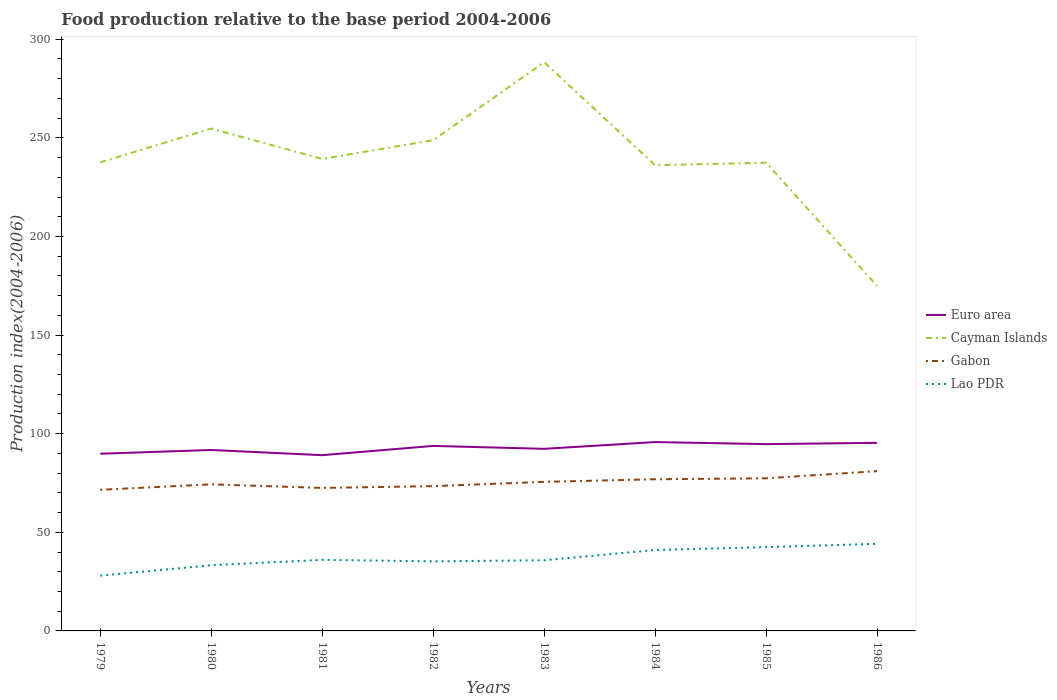How many different coloured lines are there?
Offer a terse response. 4. Does the line corresponding to Cayman Islands intersect with the line corresponding to Euro area?
Ensure brevity in your answer.  No. Is the number of lines equal to the number of legend labels?
Ensure brevity in your answer.  Yes. Across all years, what is the maximum food production index in Gabon?
Your answer should be very brief. 71.57. In which year was the food production index in Gabon maximum?
Give a very brief answer. 1979. What is the total food production index in Gabon in the graph?
Provide a succinct answer. -5.81. What is the difference between the highest and the second highest food production index in Gabon?
Keep it short and to the point. 9.44. What is the difference between the highest and the lowest food production index in Cayman Islands?
Ensure brevity in your answer.  3. Is the food production index in Lao PDR strictly greater than the food production index in Cayman Islands over the years?
Your answer should be compact. Yes. How many years are there in the graph?
Your answer should be very brief. 8. What is the difference between two consecutive major ticks on the Y-axis?
Make the answer very short. 50. Does the graph contain any zero values?
Provide a succinct answer. No. How many legend labels are there?
Keep it short and to the point. 4. What is the title of the graph?
Your answer should be very brief. Food production relative to the base period 2004-2006. What is the label or title of the Y-axis?
Your response must be concise. Production index(2004-2006). What is the Production index(2004-2006) of Euro area in 1979?
Give a very brief answer. 89.85. What is the Production index(2004-2006) in Cayman Islands in 1979?
Your response must be concise. 237.57. What is the Production index(2004-2006) of Gabon in 1979?
Offer a terse response. 71.57. What is the Production index(2004-2006) of Lao PDR in 1979?
Provide a succinct answer. 28.02. What is the Production index(2004-2006) in Euro area in 1980?
Provide a succinct answer. 91.74. What is the Production index(2004-2006) in Cayman Islands in 1980?
Provide a short and direct response. 254.7. What is the Production index(2004-2006) in Gabon in 1980?
Your response must be concise. 74.31. What is the Production index(2004-2006) of Lao PDR in 1980?
Offer a terse response. 33.3. What is the Production index(2004-2006) in Euro area in 1981?
Keep it short and to the point. 89.11. What is the Production index(2004-2006) of Cayman Islands in 1981?
Your response must be concise. 239.32. What is the Production index(2004-2006) of Gabon in 1981?
Your answer should be compact. 72.51. What is the Production index(2004-2006) in Lao PDR in 1981?
Your answer should be compact. 36.05. What is the Production index(2004-2006) in Euro area in 1982?
Provide a succinct answer. 93.8. What is the Production index(2004-2006) in Cayman Islands in 1982?
Offer a very short reply. 248.8. What is the Production index(2004-2006) in Gabon in 1982?
Offer a very short reply. 73.41. What is the Production index(2004-2006) in Lao PDR in 1982?
Make the answer very short. 35.27. What is the Production index(2004-2006) of Euro area in 1983?
Offer a terse response. 92.33. What is the Production index(2004-2006) in Cayman Islands in 1983?
Provide a succinct answer. 288.34. What is the Production index(2004-2006) of Gabon in 1983?
Provide a succinct answer. 75.58. What is the Production index(2004-2006) of Lao PDR in 1983?
Offer a terse response. 35.83. What is the Production index(2004-2006) of Euro area in 1984?
Provide a succinct answer. 95.76. What is the Production index(2004-2006) in Cayman Islands in 1984?
Make the answer very short. 236.12. What is the Production index(2004-2006) of Gabon in 1984?
Give a very brief answer. 76.9. What is the Production index(2004-2006) in Lao PDR in 1984?
Make the answer very short. 41.04. What is the Production index(2004-2006) of Euro area in 1985?
Provide a short and direct response. 94.71. What is the Production index(2004-2006) in Cayman Islands in 1985?
Keep it short and to the point. 237.41. What is the Production index(2004-2006) in Gabon in 1985?
Ensure brevity in your answer.  77.38. What is the Production index(2004-2006) of Lao PDR in 1985?
Your response must be concise. 42.48. What is the Production index(2004-2006) of Euro area in 1986?
Offer a very short reply. 95.37. What is the Production index(2004-2006) of Cayman Islands in 1986?
Keep it short and to the point. 174.84. What is the Production index(2004-2006) of Gabon in 1986?
Your answer should be very brief. 81.01. What is the Production index(2004-2006) in Lao PDR in 1986?
Provide a succinct answer. 44.16. Across all years, what is the maximum Production index(2004-2006) of Euro area?
Provide a succinct answer. 95.76. Across all years, what is the maximum Production index(2004-2006) of Cayman Islands?
Offer a very short reply. 288.34. Across all years, what is the maximum Production index(2004-2006) in Gabon?
Your response must be concise. 81.01. Across all years, what is the maximum Production index(2004-2006) of Lao PDR?
Offer a terse response. 44.16. Across all years, what is the minimum Production index(2004-2006) of Euro area?
Your answer should be compact. 89.11. Across all years, what is the minimum Production index(2004-2006) of Cayman Islands?
Your answer should be very brief. 174.84. Across all years, what is the minimum Production index(2004-2006) in Gabon?
Ensure brevity in your answer.  71.57. Across all years, what is the minimum Production index(2004-2006) in Lao PDR?
Your response must be concise. 28.02. What is the total Production index(2004-2006) in Euro area in the graph?
Your response must be concise. 742.67. What is the total Production index(2004-2006) in Cayman Islands in the graph?
Offer a terse response. 1917.1. What is the total Production index(2004-2006) of Gabon in the graph?
Keep it short and to the point. 602.67. What is the total Production index(2004-2006) of Lao PDR in the graph?
Keep it short and to the point. 296.15. What is the difference between the Production index(2004-2006) of Euro area in 1979 and that in 1980?
Make the answer very short. -1.89. What is the difference between the Production index(2004-2006) in Cayman Islands in 1979 and that in 1980?
Offer a terse response. -17.13. What is the difference between the Production index(2004-2006) of Gabon in 1979 and that in 1980?
Offer a terse response. -2.74. What is the difference between the Production index(2004-2006) of Lao PDR in 1979 and that in 1980?
Your answer should be compact. -5.28. What is the difference between the Production index(2004-2006) in Euro area in 1979 and that in 1981?
Provide a succinct answer. 0.74. What is the difference between the Production index(2004-2006) of Cayman Islands in 1979 and that in 1981?
Keep it short and to the point. -1.75. What is the difference between the Production index(2004-2006) in Gabon in 1979 and that in 1981?
Give a very brief answer. -0.94. What is the difference between the Production index(2004-2006) of Lao PDR in 1979 and that in 1981?
Offer a terse response. -8.03. What is the difference between the Production index(2004-2006) in Euro area in 1979 and that in 1982?
Your answer should be compact. -3.96. What is the difference between the Production index(2004-2006) in Cayman Islands in 1979 and that in 1982?
Give a very brief answer. -11.23. What is the difference between the Production index(2004-2006) in Gabon in 1979 and that in 1982?
Provide a short and direct response. -1.84. What is the difference between the Production index(2004-2006) in Lao PDR in 1979 and that in 1982?
Provide a succinct answer. -7.25. What is the difference between the Production index(2004-2006) in Euro area in 1979 and that in 1983?
Ensure brevity in your answer.  -2.48. What is the difference between the Production index(2004-2006) of Cayman Islands in 1979 and that in 1983?
Provide a succinct answer. -50.77. What is the difference between the Production index(2004-2006) of Gabon in 1979 and that in 1983?
Your answer should be compact. -4.01. What is the difference between the Production index(2004-2006) in Lao PDR in 1979 and that in 1983?
Your response must be concise. -7.81. What is the difference between the Production index(2004-2006) in Euro area in 1979 and that in 1984?
Give a very brief answer. -5.91. What is the difference between the Production index(2004-2006) in Cayman Islands in 1979 and that in 1984?
Provide a short and direct response. 1.45. What is the difference between the Production index(2004-2006) of Gabon in 1979 and that in 1984?
Provide a short and direct response. -5.33. What is the difference between the Production index(2004-2006) of Lao PDR in 1979 and that in 1984?
Ensure brevity in your answer.  -13.02. What is the difference between the Production index(2004-2006) of Euro area in 1979 and that in 1985?
Give a very brief answer. -4.86. What is the difference between the Production index(2004-2006) in Cayman Islands in 1979 and that in 1985?
Offer a very short reply. 0.16. What is the difference between the Production index(2004-2006) of Gabon in 1979 and that in 1985?
Your answer should be compact. -5.81. What is the difference between the Production index(2004-2006) in Lao PDR in 1979 and that in 1985?
Your response must be concise. -14.46. What is the difference between the Production index(2004-2006) of Euro area in 1979 and that in 1986?
Give a very brief answer. -5.52. What is the difference between the Production index(2004-2006) in Cayman Islands in 1979 and that in 1986?
Provide a succinct answer. 62.73. What is the difference between the Production index(2004-2006) in Gabon in 1979 and that in 1986?
Your answer should be very brief. -9.44. What is the difference between the Production index(2004-2006) of Lao PDR in 1979 and that in 1986?
Provide a succinct answer. -16.14. What is the difference between the Production index(2004-2006) in Euro area in 1980 and that in 1981?
Make the answer very short. 2.63. What is the difference between the Production index(2004-2006) of Cayman Islands in 1980 and that in 1981?
Keep it short and to the point. 15.38. What is the difference between the Production index(2004-2006) of Lao PDR in 1980 and that in 1981?
Offer a terse response. -2.75. What is the difference between the Production index(2004-2006) of Euro area in 1980 and that in 1982?
Provide a short and direct response. -2.06. What is the difference between the Production index(2004-2006) of Gabon in 1980 and that in 1982?
Provide a succinct answer. 0.9. What is the difference between the Production index(2004-2006) of Lao PDR in 1980 and that in 1982?
Give a very brief answer. -1.97. What is the difference between the Production index(2004-2006) of Euro area in 1980 and that in 1983?
Offer a very short reply. -0.59. What is the difference between the Production index(2004-2006) in Cayman Islands in 1980 and that in 1983?
Your response must be concise. -33.64. What is the difference between the Production index(2004-2006) in Gabon in 1980 and that in 1983?
Provide a short and direct response. -1.27. What is the difference between the Production index(2004-2006) in Lao PDR in 1980 and that in 1983?
Keep it short and to the point. -2.53. What is the difference between the Production index(2004-2006) of Euro area in 1980 and that in 1984?
Offer a very short reply. -4.02. What is the difference between the Production index(2004-2006) in Cayman Islands in 1980 and that in 1984?
Make the answer very short. 18.58. What is the difference between the Production index(2004-2006) of Gabon in 1980 and that in 1984?
Ensure brevity in your answer.  -2.59. What is the difference between the Production index(2004-2006) in Lao PDR in 1980 and that in 1984?
Provide a succinct answer. -7.74. What is the difference between the Production index(2004-2006) of Euro area in 1980 and that in 1985?
Your answer should be very brief. -2.97. What is the difference between the Production index(2004-2006) in Cayman Islands in 1980 and that in 1985?
Your answer should be compact. 17.29. What is the difference between the Production index(2004-2006) of Gabon in 1980 and that in 1985?
Make the answer very short. -3.07. What is the difference between the Production index(2004-2006) in Lao PDR in 1980 and that in 1985?
Give a very brief answer. -9.18. What is the difference between the Production index(2004-2006) of Euro area in 1980 and that in 1986?
Keep it short and to the point. -3.63. What is the difference between the Production index(2004-2006) in Cayman Islands in 1980 and that in 1986?
Provide a short and direct response. 79.86. What is the difference between the Production index(2004-2006) of Lao PDR in 1980 and that in 1986?
Make the answer very short. -10.86. What is the difference between the Production index(2004-2006) in Euro area in 1981 and that in 1982?
Offer a terse response. -4.69. What is the difference between the Production index(2004-2006) in Cayman Islands in 1981 and that in 1982?
Provide a short and direct response. -9.48. What is the difference between the Production index(2004-2006) in Gabon in 1981 and that in 1982?
Your answer should be compact. -0.9. What is the difference between the Production index(2004-2006) of Lao PDR in 1981 and that in 1982?
Make the answer very short. 0.78. What is the difference between the Production index(2004-2006) in Euro area in 1981 and that in 1983?
Your answer should be very brief. -3.22. What is the difference between the Production index(2004-2006) in Cayman Islands in 1981 and that in 1983?
Offer a very short reply. -49.02. What is the difference between the Production index(2004-2006) in Gabon in 1981 and that in 1983?
Give a very brief answer. -3.07. What is the difference between the Production index(2004-2006) of Lao PDR in 1981 and that in 1983?
Ensure brevity in your answer.  0.22. What is the difference between the Production index(2004-2006) of Euro area in 1981 and that in 1984?
Offer a terse response. -6.65. What is the difference between the Production index(2004-2006) of Gabon in 1981 and that in 1984?
Provide a succinct answer. -4.39. What is the difference between the Production index(2004-2006) of Lao PDR in 1981 and that in 1984?
Ensure brevity in your answer.  -4.99. What is the difference between the Production index(2004-2006) of Euro area in 1981 and that in 1985?
Your answer should be very brief. -5.6. What is the difference between the Production index(2004-2006) in Cayman Islands in 1981 and that in 1985?
Your response must be concise. 1.91. What is the difference between the Production index(2004-2006) of Gabon in 1981 and that in 1985?
Offer a very short reply. -4.87. What is the difference between the Production index(2004-2006) in Lao PDR in 1981 and that in 1985?
Provide a succinct answer. -6.43. What is the difference between the Production index(2004-2006) in Euro area in 1981 and that in 1986?
Your response must be concise. -6.26. What is the difference between the Production index(2004-2006) of Cayman Islands in 1981 and that in 1986?
Your answer should be very brief. 64.48. What is the difference between the Production index(2004-2006) of Lao PDR in 1981 and that in 1986?
Offer a very short reply. -8.11. What is the difference between the Production index(2004-2006) in Euro area in 1982 and that in 1983?
Your answer should be compact. 1.47. What is the difference between the Production index(2004-2006) in Cayman Islands in 1982 and that in 1983?
Give a very brief answer. -39.54. What is the difference between the Production index(2004-2006) of Gabon in 1982 and that in 1983?
Your answer should be very brief. -2.17. What is the difference between the Production index(2004-2006) of Lao PDR in 1982 and that in 1983?
Make the answer very short. -0.56. What is the difference between the Production index(2004-2006) of Euro area in 1982 and that in 1984?
Give a very brief answer. -1.95. What is the difference between the Production index(2004-2006) of Cayman Islands in 1982 and that in 1984?
Give a very brief answer. 12.68. What is the difference between the Production index(2004-2006) of Gabon in 1982 and that in 1984?
Provide a short and direct response. -3.49. What is the difference between the Production index(2004-2006) in Lao PDR in 1982 and that in 1984?
Offer a terse response. -5.77. What is the difference between the Production index(2004-2006) in Euro area in 1982 and that in 1985?
Your answer should be compact. -0.91. What is the difference between the Production index(2004-2006) in Cayman Islands in 1982 and that in 1985?
Provide a succinct answer. 11.39. What is the difference between the Production index(2004-2006) of Gabon in 1982 and that in 1985?
Offer a very short reply. -3.97. What is the difference between the Production index(2004-2006) of Lao PDR in 1982 and that in 1985?
Offer a terse response. -7.21. What is the difference between the Production index(2004-2006) in Euro area in 1982 and that in 1986?
Give a very brief answer. -1.56. What is the difference between the Production index(2004-2006) in Cayman Islands in 1982 and that in 1986?
Make the answer very short. 73.96. What is the difference between the Production index(2004-2006) of Lao PDR in 1982 and that in 1986?
Your answer should be compact. -8.89. What is the difference between the Production index(2004-2006) in Euro area in 1983 and that in 1984?
Keep it short and to the point. -3.43. What is the difference between the Production index(2004-2006) in Cayman Islands in 1983 and that in 1984?
Offer a terse response. 52.22. What is the difference between the Production index(2004-2006) in Gabon in 1983 and that in 1984?
Make the answer very short. -1.32. What is the difference between the Production index(2004-2006) of Lao PDR in 1983 and that in 1984?
Offer a terse response. -5.21. What is the difference between the Production index(2004-2006) of Euro area in 1983 and that in 1985?
Ensure brevity in your answer.  -2.38. What is the difference between the Production index(2004-2006) in Cayman Islands in 1983 and that in 1985?
Your answer should be very brief. 50.93. What is the difference between the Production index(2004-2006) of Gabon in 1983 and that in 1985?
Your response must be concise. -1.8. What is the difference between the Production index(2004-2006) of Lao PDR in 1983 and that in 1985?
Offer a very short reply. -6.65. What is the difference between the Production index(2004-2006) of Euro area in 1983 and that in 1986?
Your answer should be compact. -3.04. What is the difference between the Production index(2004-2006) of Cayman Islands in 1983 and that in 1986?
Your answer should be very brief. 113.5. What is the difference between the Production index(2004-2006) of Gabon in 1983 and that in 1986?
Make the answer very short. -5.43. What is the difference between the Production index(2004-2006) of Lao PDR in 1983 and that in 1986?
Offer a terse response. -8.33. What is the difference between the Production index(2004-2006) in Euro area in 1984 and that in 1985?
Make the answer very short. 1.05. What is the difference between the Production index(2004-2006) in Cayman Islands in 1984 and that in 1985?
Provide a succinct answer. -1.29. What is the difference between the Production index(2004-2006) of Gabon in 1984 and that in 1985?
Provide a succinct answer. -0.48. What is the difference between the Production index(2004-2006) in Lao PDR in 1984 and that in 1985?
Your answer should be compact. -1.44. What is the difference between the Production index(2004-2006) of Euro area in 1984 and that in 1986?
Your answer should be very brief. 0.39. What is the difference between the Production index(2004-2006) of Cayman Islands in 1984 and that in 1986?
Your response must be concise. 61.28. What is the difference between the Production index(2004-2006) in Gabon in 1984 and that in 1986?
Make the answer very short. -4.11. What is the difference between the Production index(2004-2006) of Lao PDR in 1984 and that in 1986?
Offer a terse response. -3.12. What is the difference between the Production index(2004-2006) of Euro area in 1985 and that in 1986?
Your answer should be very brief. -0.66. What is the difference between the Production index(2004-2006) of Cayman Islands in 1985 and that in 1986?
Your response must be concise. 62.57. What is the difference between the Production index(2004-2006) in Gabon in 1985 and that in 1986?
Ensure brevity in your answer.  -3.63. What is the difference between the Production index(2004-2006) of Lao PDR in 1985 and that in 1986?
Your answer should be compact. -1.68. What is the difference between the Production index(2004-2006) in Euro area in 1979 and the Production index(2004-2006) in Cayman Islands in 1980?
Offer a terse response. -164.85. What is the difference between the Production index(2004-2006) of Euro area in 1979 and the Production index(2004-2006) of Gabon in 1980?
Your answer should be very brief. 15.54. What is the difference between the Production index(2004-2006) of Euro area in 1979 and the Production index(2004-2006) of Lao PDR in 1980?
Provide a succinct answer. 56.55. What is the difference between the Production index(2004-2006) of Cayman Islands in 1979 and the Production index(2004-2006) of Gabon in 1980?
Provide a short and direct response. 163.26. What is the difference between the Production index(2004-2006) of Cayman Islands in 1979 and the Production index(2004-2006) of Lao PDR in 1980?
Your answer should be compact. 204.27. What is the difference between the Production index(2004-2006) in Gabon in 1979 and the Production index(2004-2006) in Lao PDR in 1980?
Your response must be concise. 38.27. What is the difference between the Production index(2004-2006) in Euro area in 1979 and the Production index(2004-2006) in Cayman Islands in 1981?
Provide a short and direct response. -149.47. What is the difference between the Production index(2004-2006) of Euro area in 1979 and the Production index(2004-2006) of Gabon in 1981?
Provide a short and direct response. 17.34. What is the difference between the Production index(2004-2006) of Euro area in 1979 and the Production index(2004-2006) of Lao PDR in 1981?
Your answer should be very brief. 53.8. What is the difference between the Production index(2004-2006) in Cayman Islands in 1979 and the Production index(2004-2006) in Gabon in 1981?
Provide a short and direct response. 165.06. What is the difference between the Production index(2004-2006) of Cayman Islands in 1979 and the Production index(2004-2006) of Lao PDR in 1981?
Make the answer very short. 201.52. What is the difference between the Production index(2004-2006) in Gabon in 1979 and the Production index(2004-2006) in Lao PDR in 1981?
Provide a short and direct response. 35.52. What is the difference between the Production index(2004-2006) in Euro area in 1979 and the Production index(2004-2006) in Cayman Islands in 1982?
Your response must be concise. -158.95. What is the difference between the Production index(2004-2006) in Euro area in 1979 and the Production index(2004-2006) in Gabon in 1982?
Your answer should be compact. 16.44. What is the difference between the Production index(2004-2006) of Euro area in 1979 and the Production index(2004-2006) of Lao PDR in 1982?
Provide a short and direct response. 54.58. What is the difference between the Production index(2004-2006) in Cayman Islands in 1979 and the Production index(2004-2006) in Gabon in 1982?
Provide a succinct answer. 164.16. What is the difference between the Production index(2004-2006) in Cayman Islands in 1979 and the Production index(2004-2006) in Lao PDR in 1982?
Ensure brevity in your answer.  202.3. What is the difference between the Production index(2004-2006) of Gabon in 1979 and the Production index(2004-2006) of Lao PDR in 1982?
Provide a short and direct response. 36.3. What is the difference between the Production index(2004-2006) of Euro area in 1979 and the Production index(2004-2006) of Cayman Islands in 1983?
Provide a short and direct response. -198.49. What is the difference between the Production index(2004-2006) in Euro area in 1979 and the Production index(2004-2006) in Gabon in 1983?
Your response must be concise. 14.27. What is the difference between the Production index(2004-2006) in Euro area in 1979 and the Production index(2004-2006) in Lao PDR in 1983?
Make the answer very short. 54.02. What is the difference between the Production index(2004-2006) in Cayman Islands in 1979 and the Production index(2004-2006) in Gabon in 1983?
Give a very brief answer. 161.99. What is the difference between the Production index(2004-2006) of Cayman Islands in 1979 and the Production index(2004-2006) of Lao PDR in 1983?
Provide a succinct answer. 201.74. What is the difference between the Production index(2004-2006) in Gabon in 1979 and the Production index(2004-2006) in Lao PDR in 1983?
Offer a terse response. 35.74. What is the difference between the Production index(2004-2006) of Euro area in 1979 and the Production index(2004-2006) of Cayman Islands in 1984?
Your answer should be very brief. -146.27. What is the difference between the Production index(2004-2006) of Euro area in 1979 and the Production index(2004-2006) of Gabon in 1984?
Your answer should be compact. 12.95. What is the difference between the Production index(2004-2006) of Euro area in 1979 and the Production index(2004-2006) of Lao PDR in 1984?
Offer a terse response. 48.81. What is the difference between the Production index(2004-2006) of Cayman Islands in 1979 and the Production index(2004-2006) of Gabon in 1984?
Give a very brief answer. 160.67. What is the difference between the Production index(2004-2006) of Cayman Islands in 1979 and the Production index(2004-2006) of Lao PDR in 1984?
Give a very brief answer. 196.53. What is the difference between the Production index(2004-2006) in Gabon in 1979 and the Production index(2004-2006) in Lao PDR in 1984?
Give a very brief answer. 30.53. What is the difference between the Production index(2004-2006) in Euro area in 1979 and the Production index(2004-2006) in Cayman Islands in 1985?
Offer a terse response. -147.56. What is the difference between the Production index(2004-2006) of Euro area in 1979 and the Production index(2004-2006) of Gabon in 1985?
Keep it short and to the point. 12.47. What is the difference between the Production index(2004-2006) in Euro area in 1979 and the Production index(2004-2006) in Lao PDR in 1985?
Provide a succinct answer. 47.37. What is the difference between the Production index(2004-2006) of Cayman Islands in 1979 and the Production index(2004-2006) of Gabon in 1985?
Your response must be concise. 160.19. What is the difference between the Production index(2004-2006) in Cayman Islands in 1979 and the Production index(2004-2006) in Lao PDR in 1985?
Provide a succinct answer. 195.09. What is the difference between the Production index(2004-2006) of Gabon in 1979 and the Production index(2004-2006) of Lao PDR in 1985?
Ensure brevity in your answer.  29.09. What is the difference between the Production index(2004-2006) in Euro area in 1979 and the Production index(2004-2006) in Cayman Islands in 1986?
Your response must be concise. -84.99. What is the difference between the Production index(2004-2006) in Euro area in 1979 and the Production index(2004-2006) in Gabon in 1986?
Your answer should be very brief. 8.84. What is the difference between the Production index(2004-2006) in Euro area in 1979 and the Production index(2004-2006) in Lao PDR in 1986?
Offer a very short reply. 45.69. What is the difference between the Production index(2004-2006) of Cayman Islands in 1979 and the Production index(2004-2006) of Gabon in 1986?
Provide a succinct answer. 156.56. What is the difference between the Production index(2004-2006) of Cayman Islands in 1979 and the Production index(2004-2006) of Lao PDR in 1986?
Provide a short and direct response. 193.41. What is the difference between the Production index(2004-2006) of Gabon in 1979 and the Production index(2004-2006) of Lao PDR in 1986?
Ensure brevity in your answer.  27.41. What is the difference between the Production index(2004-2006) of Euro area in 1980 and the Production index(2004-2006) of Cayman Islands in 1981?
Make the answer very short. -147.58. What is the difference between the Production index(2004-2006) of Euro area in 1980 and the Production index(2004-2006) of Gabon in 1981?
Your answer should be compact. 19.23. What is the difference between the Production index(2004-2006) in Euro area in 1980 and the Production index(2004-2006) in Lao PDR in 1981?
Your answer should be very brief. 55.69. What is the difference between the Production index(2004-2006) of Cayman Islands in 1980 and the Production index(2004-2006) of Gabon in 1981?
Your answer should be very brief. 182.19. What is the difference between the Production index(2004-2006) of Cayman Islands in 1980 and the Production index(2004-2006) of Lao PDR in 1981?
Offer a terse response. 218.65. What is the difference between the Production index(2004-2006) of Gabon in 1980 and the Production index(2004-2006) of Lao PDR in 1981?
Give a very brief answer. 38.26. What is the difference between the Production index(2004-2006) of Euro area in 1980 and the Production index(2004-2006) of Cayman Islands in 1982?
Your response must be concise. -157.06. What is the difference between the Production index(2004-2006) of Euro area in 1980 and the Production index(2004-2006) of Gabon in 1982?
Your answer should be very brief. 18.33. What is the difference between the Production index(2004-2006) in Euro area in 1980 and the Production index(2004-2006) in Lao PDR in 1982?
Keep it short and to the point. 56.47. What is the difference between the Production index(2004-2006) of Cayman Islands in 1980 and the Production index(2004-2006) of Gabon in 1982?
Provide a short and direct response. 181.29. What is the difference between the Production index(2004-2006) of Cayman Islands in 1980 and the Production index(2004-2006) of Lao PDR in 1982?
Keep it short and to the point. 219.43. What is the difference between the Production index(2004-2006) in Gabon in 1980 and the Production index(2004-2006) in Lao PDR in 1982?
Make the answer very short. 39.04. What is the difference between the Production index(2004-2006) of Euro area in 1980 and the Production index(2004-2006) of Cayman Islands in 1983?
Offer a terse response. -196.6. What is the difference between the Production index(2004-2006) in Euro area in 1980 and the Production index(2004-2006) in Gabon in 1983?
Give a very brief answer. 16.16. What is the difference between the Production index(2004-2006) of Euro area in 1980 and the Production index(2004-2006) of Lao PDR in 1983?
Make the answer very short. 55.91. What is the difference between the Production index(2004-2006) of Cayman Islands in 1980 and the Production index(2004-2006) of Gabon in 1983?
Offer a very short reply. 179.12. What is the difference between the Production index(2004-2006) of Cayman Islands in 1980 and the Production index(2004-2006) of Lao PDR in 1983?
Offer a terse response. 218.87. What is the difference between the Production index(2004-2006) in Gabon in 1980 and the Production index(2004-2006) in Lao PDR in 1983?
Your answer should be compact. 38.48. What is the difference between the Production index(2004-2006) of Euro area in 1980 and the Production index(2004-2006) of Cayman Islands in 1984?
Your answer should be compact. -144.38. What is the difference between the Production index(2004-2006) of Euro area in 1980 and the Production index(2004-2006) of Gabon in 1984?
Keep it short and to the point. 14.84. What is the difference between the Production index(2004-2006) in Euro area in 1980 and the Production index(2004-2006) in Lao PDR in 1984?
Make the answer very short. 50.7. What is the difference between the Production index(2004-2006) in Cayman Islands in 1980 and the Production index(2004-2006) in Gabon in 1984?
Give a very brief answer. 177.8. What is the difference between the Production index(2004-2006) in Cayman Islands in 1980 and the Production index(2004-2006) in Lao PDR in 1984?
Offer a terse response. 213.66. What is the difference between the Production index(2004-2006) of Gabon in 1980 and the Production index(2004-2006) of Lao PDR in 1984?
Keep it short and to the point. 33.27. What is the difference between the Production index(2004-2006) of Euro area in 1980 and the Production index(2004-2006) of Cayman Islands in 1985?
Ensure brevity in your answer.  -145.67. What is the difference between the Production index(2004-2006) of Euro area in 1980 and the Production index(2004-2006) of Gabon in 1985?
Keep it short and to the point. 14.36. What is the difference between the Production index(2004-2006) of Euro area in 1980 and the Production index(2004-2006) of Lao PDR in 1985?
Give a very brief answer. 49.26. What is the difference between the Production index(2004-2006) of Cayman Islands in 1980 and the Production index(2004-2006) of Gabon in 1985?
Offer a very short reply. 177.32. What is the difference between the Production index(2004-2006) in Cayman Islands in 1980 and the Production index(2004-2006) in Lao PDR in 1985?
Ensure brevity in your answer.  212.22. What is the difference between the Production index(2004-2006) in Gabon in 1980 and the Production index(2004-2006) in Lao PDR in 1985?
Provide a short and direct response. 31.83. What is the difference between the Production index(2004-2006) of Euro area in 1980 and the Production index(2004-2006) of Cayman Islands in 1986?
Ensure brevity in your answer.  -83.1. What is the difference between the Production index(2004-2006) in Euro area in 1980 and the Production index(2004-2006) in Gabon in 1986?
Your answer should be compact. 10.73. What is the difference between the Production index(2004-2006) in Euro area in 1980 and the Production index(2004-2006) in Lao PDR in 1986?
Provide a succinct answer. 47.58. What is the difference between the Production index(2004-2006) of Cayman Islands in 1980 and the Production index(2004-2006) of Gabon in 1986?
Ensure brevity in your answer.  173.69. What is the difference between the Production index(2004-2006) of Cayman Islands in 1980 and the Production index(2004-2006) of Lao PDR in 1986?
Your answer should be compact. 210.54. What is the difference between the Production index(2004-2006) in Gabon in 1980 and the Production index(2004-2006) in Lao PDR in 1986?
Your answer should be very brief. 30.15. What is the difference between the Production index(2004-2006) of Euro area in 1981 and the Production index(2004-2006) of Cayman Islands in 1982?
Offer a very short reply. -159.69. What is the difference between the Production index(2004-2006) in Euro area in 1981 and the Production index(2004-2006) in Gabon in 1982?
Provide a succinct answer. 15.7. What is the difference between the Production index(2004-2006) in Euro area in 1981 and the Production index(2004-2006) in Lao PDR in 1982?
Your response must be concise. 53.84. What is the difference between the Production index(2004-2006) in Cayman Islands in 1981 and the Production index(2004-2006) in Gabon in 1982?
Your answer should be compact. 165.91. What is the difference between the Production index(2004-2006) in Cayman Islands in 1981 and the Production index(2004-2006) in Lao PDR in 1982?
Keep it short and to the point. 204.05. What is the difference between the Production index(2004-2006) in Gabon in 1981 and the Production index(2004-2006) in Lao PDR in 1982?
Give a very brief answer. 37.24. What is the difference between the Production index(2004-2006) of Euro area in 1981 and the Production index(2004-2006) of Cayman Islands in 1983?
Give a very brief answer. -199.23. What is the difference between the Production index(2004-2006) of Euro area in 1981 and the Production index(2004-2006) of Gabon in 1983?
Ensure brevity in your answer.  13.53. What is the difference between the Production index(2004-2006) of Euro area in 1981 and the Production index(2004-2006) of Lao PDR in 1983?
Your answer should be compact. 53.28. What is the difference between the Production index(2004-2006) of Cayman Islands in 1981 and the Production index(2004-2006) of Gabon in 1983?
Your answer should be very brief. 163.74. What is the difference between the Production index(2004-2006) of Cayman Islands in 1981 and the Production index(2004-2006) of Lao PDR in 1983?
Offer a very short reply. 203.49. What is the difference between the Production index(2004-2006) in Gabon in 1981 and the Production index(2004-2006) in Lao PDR in 1983?
Your response must be concise. 36.68. What is the difference between the Production index(2004-2006) in Euro area in 1981 and the Production index(2004-2006) in Cayman Islands in 1984?
Make the answer very short. -147.01. What is the difference between the Production index(2004-2006) of Euro area in 1981 and the Production index(2004-2006) of Gabon in 1984?
Make the answer very short. 12.21. What is the difference between the Production index(2004-2006) of Euro area in 1981 and the Production index(2004-2006) of Lao PDR in 1984?
Provide a short and direct response. 48.07. What is the difference between the Production index(2004-2006) in Cayman Islands in 1981 and the Production index(2004-2006) in Gabon in 1984?
Your answer should be compact. 162.42. What is the difference between the Production index(2004-2006) in Cayman Islands in 1981 and the Production index(2004-2006) in Lao PDR in 1984?
Offer a very short reply. 198.28. What is the difference between the Production index(2004-2006) of Gabon in 1981 and the Production index(2004-2006) of Lao PDR in 1984?
Your answer should be compact. 31.47. What is the difference between the Production index(2004-2006) in Euro area in 1981 and the Production index(2004-2006) in Cayman Islands in 1985?
Provide a succinct answer. -148.3. What is the difference between the Production index(2004-2006) in Euro area in 1981 and the Production index(2004-2006) in Gabon in 1985?
Make the answer very short. 11.73. What is the difference between the Production index(2004-2006) in Euro area in 1981 and the Production index(2004-2006) in Lao PDR in 1985?
Keep it short and to the point. 46.63. What is the difference between the Production index(2004-2006) in Cayman Islands in 1981 and the Production index(2004-2006) in Gabon in 1985?
Offer a terse response. 161.94. What is the difference between the Production index(2004-2006) in Cayman Islands in 1981 and the Production index(2004-2006) in Lao PDR in 1985?
Make the answer very short. 196.84. What is the difference between the Production index(2004-2006) in Gabon in 1981 and the Production index(2004-2006) in Lao PDR in 1985?
Provide a succinct answer. 30.03. What is the difference between the Production index(2004-2006) of Euro area in 1981 and the Production index(2004-2006) of Cayman Islands in 1986?
Give a very brief answer. -85.73. What is the difference between the Production index(2004-2006) of Euro area in 1981 and the Production index(2004-2006) of Gabon in 1986?
Offer a very short reply. 8.1. What is the difference between the Production index(2004-2006) of Euro area in 1981 and the Production index(2004-2006) of Lao PDR in 1986?
Offer a terse response. 44.95. What is the difference between the Production index(2004-2006) of Cayman Islands in 1981 and the Production index(2004-2006) of Gabon in 1986?
Provide a succinct answer. 158.31. What is the difference between the Production index(2004-2006) in Cayman Islands in 1981 and the Production index(2004-2006) in Lao PDR in 1986?
Your answer should be compact. 195.16. What is the difference between the Production index(2004-2006) of Gabon in 1981 and the Production index(2004-2006) of Lao PDR in 1986?
Offer a very short reply. 28.35. What is the difference between the Production index(2004-2006) in Euro area in 1982 and the Production index(2004-2006) in Cayman Islands in 1983?
Provide a short and direct response. -194.54. What is the difference between the Production index(2004-2006) of Euro area in 1982 and the Production index(2004-2006) of Gabon in 1983?
Ensure brevity in your answer.  18.22. What is the difference between the Production index(2004-2006) in Euro area in 1982 and the Production index(2004-2006) in Lao PDR in 1983?
Keep it short and to the point. 57.97. What is the difference between the Production index(2004-2006) in Cayman Islands in 1982 and the Production index(2004-2006) in Gabon in 1983?
Offer a terse response. 173.22. What is the difference between the Production index(2004-2006) of Cayman Islands in 1982 and the Production index(2004-2006) of Lao PDR in 1983?
Offer a very short reply. 212.97. What is the difference between the Production index(2004-2006) in Gabon in 1982 and the Production index(2004-2006) in Lao PDR in 1983?
Ensure brevity in your answer.  37.58. What is the difference between the Production index(2004-2006) in Euro area in 1982 and the Production index(2004-2006) in Cayman Islands in 1984?
Offer a very short reply. -142.32. What is the difference between the Production index(2004-2006) of Euro area in 1982 and the Production index(2004-2006) of Gabon in 1984?
Give a very brief answer. 16.9. What is the difference between the Production index(2004-2006) of Euro area in 1982 and the Production index(2004-2006) of Lao PDR in 1984?
Your answer should be very brief. 52.76. What is the difference between the Production index(2004-2006) in Cayman Islands in 1982 and the Production index(2004-2006) in Gabon in 1984?
Your response must be concise. 171.9. What is the difference between the Production index(2004-2006) in Cayman Islands in 1982 and the Production index(2004-2006) in Lao PDR in 1984?
Your answer should be compact. 207.76. What is the difference between the Production index(2004-2006) in Gabon in 1982 and the Production index(2004-2006) in Lao PDR in 1984?
Make the answer very short. 32.37. What is the difference between the Production index(2004-2006) in Euro area in 1982 and the Production index(2004-2006) in Cayman Islands in 1985?
Make the answer very short. -143.61. What is the difference between the Production index(2004-2006) of Euro area in 1982 and the Production index(2004-2006) of Gabon in 1985?
Offer a very short reply. 16.42. What is the difference between the Production index(2004-2006) in Euro area in 1982 and the Production index(2004-2006) in Lao PDR in 1985?
Provide a short and direct response. 51.32. What is the difference between the Production index(2004-2006) in Cayman Islands in 1982 and the Production index(2004-2006) in Gabon in 1985?
Provide a short and direct response. 171.42. What is the difference between the Production index(2004-2006) of Cayman Islands in 1982 and the Production index(2004-2006) of Lao PDR in 1985?
Your answer should be compact. 206.32. What is the difference between the Production index(2004-2006) in Gabon in 1982 and the Production index(2004-2006) in Lao PDR in 1985?
Your answer should be compact. 30.93. What is the difference between the Production index(2004-2006) of Euro area in 1982 and the Production index(2004-2006) of Cayman Islands in 1986?
Give a very brief answer. -81.04. What is the difference between the Production index(2004-2006) in Euro area in 1982 and the Production index(2004-2006) in Gabon in 1986?
Provide a succinct answer. 12.79. What is the difference between the Production index(2004-2006) of Euro area in 1982 and the Production index(2004-2006) of Lao PDR in 1986?
Your response must be concise. 49.64. What is the difference between the Production index(2004-2006) of Cayman Islands in 1982 and the Production index(2004-2006) of Gabon in 1986?
Keep it short and to the point. 167.79. What is the difference between the Production index(2004-2006) in Cayman Islands in 1982 and the Production index(2004-2006) in Lao PDR in 1986?
Provide a short and direct response. 204.64. What is the difference between the Production index(2004-2006) of Gabon in 1982 and the Production index(2004-2006) of Lao PDR in 1986?
Keep it short and to the point. 29.25. What is the difference between the Production index(2004-2006) in Euro area in 1983 and the Production index(2004-2006) in Cayman Islands in 1984?
Make the answer very short. -143.79. What is the difference between the Production index(2004-2006) of Euro area in 1983 and the Production index(2004-2006) of Gabon in 1984?
Your answer should be compact. 15.43. What is the difference between the Production index(2004-2006) in Euro area in 1983 and the Production index(2004-2006) in Lao PDR in 1984?
Your answer should be very brief. 51.29. What is the difference between the Production index(2004-2006) of Cayman Islands in 1983 and the Production index(2004-2006) of Gabon in 1984?
Keep it short and to the point. 211.44. What is the difference between the Production index(2004-2006) in Cayman Islands in 1983 and the Production index(2004-2006) in Lao PDR in 1984?
Offer a terse response. 247.3. What is the difference between the Production index(2004-2006) in Gabon in 1983 and the Production index(2004-2006) in Lao PDR in 1984?
Your response must be concise. 34.54. What is the difference between the Production index(2004-2006) in Euro area in 1983 and the Production index(2004-2006) in Cayman Islands in 1985?
Offer a terse response. -145.08. What is the difference between the Production index(2004-2006) in Euro area in 1983 and the Production index(2004-2006) in Gabon in 1985?
Offer a terse response. 14.95. What is the difference between the Production index(2004-2006) of Euro area in 1983 and the Production index(2004-2006) of Lao PDR in 1985?
Provide a succinct answer. 49.85. What is the difference between the Production index(2004-2006) in Cayman Islands in 1983 and the Production index(2004-2006) in Gabon in 1985?
Give a very brief answer. 210.96. What is the difference between the Production index(2004-2006) in Cayman Islands in 1983 and the Production index(2004-2006) in Lao PDR in 1985?
Keep it short and to the point. 245.86. What is the difference between the Production index(2004-2006) of Gabon in 1983 and the Production index(2004-2006) of Lao PDR in 1985?
Give a very brief answer. 33.1. What is the difference between the Production index(2004-2006) of Euro area in 1983 and the Production index(2004-2006) of Cayman Islands in 1986?
Your answer should be very brief. -82.51. What is the difference between the Production index(2004-2006) of Euro area in 1983 and the Production index(2004-2006) of Gabon in 1986?
Your answer should be compact. 11.32. What is the difference between the Production index(2004-2006) in Euro area in 1983 and the Production index(2004-2006) in Lao PDR in 1986?
Your answer should be very brief. 48.17. What is the difference between the Production index(2004-2006) of Cayman Islands in 1983 and the Production index(2004-2006) of Gabon in 1986?
Ensure brevity in your answer.  207.33. What is the difference between the Production index(2004-2006) of Cayman Islands in 1983 and the Production index(2004-2006) of Lao PDR in 1986?
Give a very brief answer. 244.18. What is the difference between the Production index(2004-2006) in Gabon in 1983 and the Production index(2004-2006) in Lao PDR in 1986?
Make the answer very short. 31.42. What is the difference between the Production index(2004-2006) in Euro area in 1984 and the Production index(2004-2006) in Cayman Islands in 1985?
Your answer should be compact. -141.65. What is the difference between the Production index(2004-2006) of Euro area in 1984 and the Production index(2004-2006) of Gabon in 1985?
Your response must be concise. 18.38. What is the difference between the Production index(2004-2006) in Euro area in 1984 and the Production index(2004-2006) in Lao PDR in 1985?
Provide a short and direct response. 53.28. What is the difference between the Production index(2004-2006) of Cayman Islands in 1984 and the Production index(2004-2006) of Gabon in 1985?
Your response must be concise. 158.74. What is the difference between the Production index(2004-2006) of Cayman Islands in 1984 and the Production index(2004-2006) of Lao PDR in 1985?
Your answer should be very brief. 193.64. What is the difference between the Production index(2004-2006) in Gabon in 1984 and the Production index(2004-2006) in Lao PDR in 1985?
Provide a succinct answer. 34.42. What is the difference between the Production index(2004-2006) of Euro area in 1984 and the Production index(2004-2006) of Cayman Islands in 1986?
Offer a very short reply. -79.08. What is the difference between the Production index(2004-2006) in Euro area in 1984 and the Production index(2004-2006) in Gabon in 1986?
Provide a succinct answer. 14.75. What is the difference between the Production index(2004-2006) in Euro area in 1984 and the Production index(2004-2006) in Lao PDR in 1986?
Offer a terse response. 51.6. What is the difference between the Production index(2004-2006) in Cayman Islands in 1984 and the Production index(2004-2006) in Gabon in 1986?
Provide a short and direct response. 155.11. What is the difference between the Production index(2004-2006) in Cayman Islands in 1984 and the Production index(2004-2006) in Lao PDR in 1986?
Your answer should be very brief. 191.96. What is the difference between the Production index(2004-2006) of Gabon in 1984 and the Production index(2004-2006) of Lao PDR in 1986?
Provide a succinct answer. 32.74. What is the difference between the Production index(2004-2006) of Euro area in 1985 and the Production index(2004-2006) of Cayman Islands in 1986?
Offer a terse response. -80.13. What is the difference between the Production index(2004-2006) in Euro area in 1985 and the Production index(2004-2006) in Gabon in 1986?
Your response must be concise. 13.7. What is the difference between the Production index(2004-2006) in Euro area in 1985 and the Production index(2004-2006) in Lao PDR in 1986?
Give a very brief answer. 50.55. What is the difference between the Production index(2004-2006) of Cayman Islands in 1985 and the Production index(2004-2006) of Gabon in 1986?
Keep it short and to the point. 156.4. What is the difference between the Production index(2004-2006) of Cayman Islands in 1985 and the Production index(2004-2006) of Lao PDR in 1986?
Offer a very short reply. 193.25. What is the difference between the Production index(2004-2006) of Gabon in 1985 and the Production index(2004-2006) of Lao PDR in 1986?
Offer a very short reply. 33.22. What is the average Production index(2004-2006) of Euro area per year?
Offer a terse response. 92.83. What is the average Production index(2004-2006) in Cayman Islands per year?
Keep it short and to the point. 239.64. What is the average Production index(2004-2006) of Gabon per year?
Offer a very short reply. 75.33. What is the average Production index(2004-2006) of Lao PDR per year?
Provide a short and direct response. 37.02. In the year 1979, what is the difference between the Production index(2004-2006) of Euro area and Production index(2004-2006) of Cayman Islands?
Keep it short and to the point. -147.72. In the year 1979, what is the difference between the Production index(2004-2006) of Euro area and Production index(2004-2006) of Gabon?
Your answer should be very brief. 18.28. In the year 1979, what is the difference between the Production index(2004-2006) of Euro area and Production index(2004-2006) of Lao PDR?
Offer a very short reply. 61.83. In the year 1979, what is the difference between the Production index(2004-2006) in Cayman Islands and Production index(2004-2006) in Gabon?
Your answer should be compact. 166. In the year 1979, what is the difference between the Production index(2004-2006) of Cayman Islands and Production index(2004-2006) of Lao PDR?
Offer a terse response. 209.55. In the year 1979, what is the difference between the Production index(2004-2006) of Gabon and Production index(2004-2006) of Lao PDR?
Provide a short and direct response. 43.55. In the year 1980, what is the difference between the Production index(2004-2006) in Euro area and Production index(2004-2006) in Cayman Islands?
Your answer should be very brief. -162.96. In the year 1980, what is the difference between the Production index(2004-2006) in Euro area and Production index(2004-2006) in Gabon?
Your answer should be very brief. 17.43. In the year 1980, what is the difference between the Production index(2004-2006) in Euro area and Production index(2004-2006) in Lao PDR?
Ensure brevity in your answer.  58.44. In the year 1980, what is the difference between the Production index(2004-2006) in Cayman Islands and Production index(2004-2006) in Gabon?
Offer a very short reply. 180.39. In the year 1980, what is the difference between the Production index(2004-2006) of Cayman Islands and Production index(2004-2006) of Lao PDR?
Your answer should be very brief. 221.4. In the year 1980, what is the difference between the Production index(2004-2006) in Gabon and Production index(2004-2006) in Lao PDR?
Ensure brevity in your answer.  41.01. In the year 1981, what is the difference between the Production index(2004-2006) of Euro area and Production index(2004-2006) of Cayman Islands?
Provide a succinct answer. -150.21. In the year 1981, what is the difference between the Production index(2004-2006) of Euro area and Production index(2004-2006) of Gabon?
Keep it short and to the point. 16.6. In the year 1981, what is the difference between the Production index(2004-2006) in Euro area and Production index(2004-2006) in Lao PDR?
Provide a short and direct response. 53.06. In the year 1981, what is the difference between the Production index(2004-2006) of Cayman Islands and Production index(2004-2006) of Gabon?
Ensure brevity in your answer.  166.81. In the year 1981, what is the difference between the Production index(2004-2006) of Cayman Islands and Production index(2004-2006) of Lao PDR?
Make the answer very short. 203.27. In the year 1981, what is the difference between the Production index(2004-2006) of Gabon and Production index(2004-2006) of Lao PDR?
Provide a succinct answer. 36.46. In the year 1982, what is the difference between the Production index(2004-2006) of Euro area and Production index(2004-2006) of Cayman Islands?
Your answer should be compact. -155. In the year 1982, what is the difference between the Production index(2004-2006) in Euro area and Production index(2004-2006) in Gabon?
Make the answer very short. 20.39. In the year 1982, what is the difference between the Production index(2004-2006) in Euro area and Production index(2004-2006) in Lao PDR?
Give a very brief answer. 58.53. In the year 1982, what is the difference between the Production index(2004-2006) in Cayman Islands and Production index(2004-2006) in Gabon?
Offer a terse response. 175.39. In the year 1982, what is the difference between the Production index(2004-2006) of Cayman Islands and Production index(2004-2006) of Lao PDR?
Keep it short and to the point. 213.53. In the year 1982, what is the difference between the Production index(2004-2006) in Gabon and Production index(2004-2006) in Lao PDR?
Ensure brevity in your answer.  38.14. In the year 1983, what is the difference between the Production index(2004-2006) of Euro area and Production index(2004-2006) of Cayman Islands?
Offer a very short reply. -196.01. In the year 1983, what is the difference between the Production index(2004-2006) of Euro area and Production index(2004-2006) of Gabon?
Your answer should be compact. 16.75. In the year 1983, what is the difference between the Production index(2004-2006) in Euro area and Production index(2004-2006) in Lao PDR?
Your answer should be very brief. 56.5. In the year 1983, what is the difference between the Production index(2004-2006) in Cayman Islands and Production index(2004-2006) in Gabon?
Provide a short and direct response. 212.76. In the year 1983, what is the difference between the Production index(2004-2006) of Cayman Islands and Production index(2004-2006) of Lao PDR?
Offer a very short reply. 252.51. In the year 1983, what is the difference between the Production index(2004-2006) of Gabon and Production index(2004-2006) of Lao PDR?
Offer a very short reply. 39.75. In the year 1984, what is the difference between the Production index(2004-2006) in Euro area and Production index(2004-2006) in Cayman Islands?
Give a very brief answer. -140.36. In the year 1984, what is the difference between the Production index(2004-2006) of Euro area and Production index(2004-2006) of Gabon?
Provide a succinct answer. 18.86. In the year 1984, what is the difference between the Production index(2004-2006) of Euro area and Production index(2004-2006) of Lao PDR?
Give a very brief answer. 54.72. In the year 1984, what is the difference between the Production index(2004-2006) in Cayman Islands and Production index(2004-2006) in Gabon?
Your answer should be very brief. 159.22. In the year 1984, what is the difference between the Production index(2004-2006) in Cayman Islands and Production index(2004-2006) in Lao PDR?
Make the answer very short. 195.08. In the year 1984, what is the difference between the Production index(2004-2006) of Gabon and Production index(2004-2006) of Lao PDR?
Ensure brevity in your answer.  35.86. In the year 1985, what is the difference between the Production index(2004-2006) of Euro area and Production index(2004-2006) of Cayman Islands?
Provide a succinct answer. -142.7. In the year 1985, what is the difference between the Production index(2004-2006) of Euro area and Production index(2004-2006) of Gabon?
Provide a succinct answer. 17.33. In the year 1985, what is the difference between the Production index(2004-2006) of Euro area and Production index(2004-2006) of Lao PDR?
Offer a terse response. 52.23. In the year 1985, what is the difference between the Production index(2004-2006) in Cayman Islands and Production index(2004-2006) in Gabon?
Provide a succinct answer. 160.03. In the year 1985, what is the difference between the Production index(2004-2006) of Cayman Islands and Production index(2004-2006) of Lao PDR?
Offer a terse response. 194.93. In the year 1985, what is the difference between the Production index(2004-2006) of Gabon and Production index(2004-2006) of Lao PDR?
Your answer should be compact. 34.9. In the year 1986, what is the difference between the Production index(2004-2006) of Euro area and Production index(2004-2006) of Cayman Islands?
Your answer should be compact. -79.47. In the year 1986, what is the difference between the Production index(2004-2006) of Euro area and Production index(2004-2006) of Gabon?
Ensure brevity in your answer.  14.36. In the year 1986, what is the difference between the Production index(2004-2006) in Euro area and Production index(2004-2006) in Lao PDR?
Ensure brevity in your answer.  51.21. In the year 1986, what is the difference between the Production index(2004-2006) in Cayman Islands and Production index(2004-2006) in Gabon?
Your answer should be compact. 93.83. In the year 1986, what is the difference between the Production index(2004-2006) in Cayman Islands and Production index(2004-2006) in Lao PDR?
Offer a very short reply. 130.68. In the year 1986, what is the difference between the Production index(2004-2006) of Gabon and Production index(2004-2006) of Lao PDR?
Offer a terse response. 36.85. What is the ratio of the Production index(2004-2006) in Euro area in 1979 to that in 1980?
Make the answer very short. 0.98. What is the ratio of the Production index(2004-2006) in Cayman Islands in 1979 to that in 1980?
Your answer should be compact. 0.93. What is the ratio of the Production index(2004-2006) of Gabon in 1979 to that in 1980?
Your answer should be very brief. 0.96. What is the ratio of the Production index(2004-2006) in Lao PDR in 1979 to that in 1980?
Provide a succinct answer. 0.84. What is the ratio of the Production index(2004-2006) in Euro area in 1979 to that in 1981?
Ensure brevity in your answer.  1.01. What is the ratio of the Production index(2004-2006) of Cayman Islands in 1979 to that in 1981?
Your answer should be very brief. 0.99. What is the ratio of the Production index(2004-2006) in Gabon in 1979 to that in 1981?
Your answer should be very brief. 0.99. What is the ratio of the Production index(2004-2006) in Lao PDR in 1979 to that in 1981?
Make the answer very short. 0.78. What is the ratio of the Production index(2004-2006) in Euro area in 1979 to that in 1982?
Your answer should be very brief. 0.96. What is the ratio of the Production index(2004-2006) in Cayman Islands in 1979 to that in 1982?
Ensure brevity in your answer.  0.95. What is the ratio of the Production index(2004-2006) in Gabon in 1979 to that in 1982?
Give a very brief answer. 0.97. What is the ratio of the Production index(2004-2006) of Lao PDR in 1979 to that in 1982?
Provide a short and direct response. 0.79. What is the ratio of the Production index(2004-2006) of Euro area in 1979 to that in 1983?
Ensure brevity in your answer.  0.97. What is the ratio of the Production index(2004-2006) of Cayman Islands in 1979 to that in 1983?
Provide a short and direct response. 0.82. What is the ratio of the Production index(2004-2006) in Gabon in 1979 to that in 1983?
Give a very brief answer. 0.95. What is the ratio of the Production index(2004-2006) in Lao PDR in 1979 to that in 1983?
Give a very brief answer. 0.78. What is the ratio of the Production index(2004-2006) of Euro area in 1979 to that in 1984?
Give a very brief answer. 0.94. What is the ratio of the Production index(2004-2006) in Cayman Islands in 1979 to that in 1984?
Your answer should be very brief. 1.01. What is the ratio of the Production index(2004-2006) in Gabon in 1979 to that in 1984?
Provide a succinct answer. 0.93. What is the ratio of the Production index(2004-2006) in Lao PDR in 1979 to that in 1984?
Offer a terse response. 0.68. What is the ratio of the Production index(2004-2006) of Euro area in 1979 to that in 1985?
Offer a very short reply. 0.95. What is the ratio of the Production index(2004-2006) of Gabon in 1979 to that in 1985?
Make the answer very short. 0.92. What is the ratio of the Production index(2004-2006) of Lao PDR in 1979 to that in 1985?
Provide a succinct answer. 0.66. What is the ratio of the Production index(2004-2006) of Euro area in 1979 to that in 1986?
Your response must be concise. 0.94. What is the ratio of the Production index(2004-2006) in Cayman Islands in 1979 to that in 1986?
Give a very brief answer. 1.36. What is the ratio of the Production index(2004-2006) in Gabon in 1979 to that in 1986?
Give a very brief answer. 0.88. What is the ratio of the Production index(2004-2006) of Lao PDR in 1979 to that in 1986?
Your answer should be compact. 0.63. What is the ratio of the Production index(2004-2006) of Euro area in 1980 to that in 1981?
Ensure brevity in your answer.  1.03. What is the ratio of the Production index(2004-2006) in Cayman Islands in 1980 to that in 1981?
Offer a terse response. 1.06. What is the ratio of the Production index(2004-2006) of Gabon in 1980 to that in 1981?
Your answer should be very brief. 1.02. What is the ratio of the Production index(2004-2006) in Lao PDR in 1980 to that in 1981?
Make the answer very short. 0.92. What is the ratio of the Production index(2004-2006) in Euro area in 1980 to that in 1982?
Ensure brevity in your answer.  0.98. What is the ratio of the Production index(2004-2006) in Cayman Islands in 1980 to that in 1982?
Ensure brevity in your answer.  1.02. What is the ratio of the Production index(2004-2006) of Gabon in 1980 to that in 1982?
Keep it short and to the point. 1.01. What is the ratio of the Production index(2004-2006) in Lao PDR in 1980 to that in 1982?
Your response must be concise. 0.94. What is the ratio of the Production index(2004-2006) in Euro area in 1980 to that in 1983?
Offer a terse response. 0.99. What is the ratio of the Production index(2004-2006) of Cayman Islands in 1980 to that in 1983?
Give a very brief answer. 0.88. What is the ratio of the Production index(2004-2006) of Gabon in 1980 to that in 1983?
Your answer should be very brief. 0.98. What is the ratio of the Production index(2004-2006) of Lao PDR in 1980 to that in 1983?
Your response must be concise. 0.93. What is the ratio of the Production index(2004-2006) in Euro area in 1980 to that in 1984?
Keep it short and to the point. 0.96. What is the ratio of the Production index(2004-2006) in Cayman Islands in 1980 to that in 1984?
Provide a short and direct response. 1.08. What is the ratio of the Production index(2004-2006) of Gabon in 1980 to that in 1984?
Your answer should be very brief. 0.97. What is the ratio of the Production index(2004-2006) of Lao PDR in 1980 to that in 1984?
Your answer should be very brief. 0.81. What is the ratio of the Production index(2004-2006) in Euro area in 1980 to that in 1985?
Your answer should be compact. 0.97. What is the ratio of the Production index(2004-2006) of Cayman Islands in 1980 to that in 1985?
Provide a short and direct response. 1.07. What is the ratio of the Production index(2004-2006) in Gabon in 1980 to that in 1985?
Provide a succinct answer. 0.96. What is the ratio of the Production index(2004-2006) in Lao PDR in 1980 to that in 1985?
Your answer should be compact. 0.78. What is the ratio of the Production index(2004-2006) in Euro area in 1980 to that in 1986?
Your answer should be very brief. 0.96. What is the ratio of the Production index(2004-2006) in Cayman Islands in 1980 to that in 1986?
Offer a terse response. 1.46. What is the ratio of the Production index(2004-2006) in Gabon in 1980 to that in 1986?
Your answer should be very brief. 0.92. What is the ratio of the Production index(2004-2006) in Lao PDR in 1980 to that in 1986?
Provide a succinct answer. 0.75. What is the ratio of the Production index(2004-2006) in Cayman Islands in 1981 to that in 1982?
Ensure brevity in your answer.  0.96. What is the ratio of the Production index(2004-2006) of Lao PDR in 1981 to that in 1982?
Make the answer very short. 1.02. What is the ratio of the Production index(2004-2006) of Euro area in 1981 to that in 1983?
Make the answer very short. 0.97. What is the ratio of the Production index(2004-2006) of Cayman Islands in 1981 to that in 1983?
Offer a very short reply. 0.83. What is the ratio of the Production index(2004-2006) in Gabon in 1981 to that in 1983?
Your answer should be compact. 0.96. What is the ratio of the Production index(2004-2006) of Euro area in 1981 to that in 1984?
Keep it short and to the point. 0.93. What is the ratio of the Production index(2004-2006) in Cayman Islands in 1981 to that in 1984?
Provide a short and direct response. 1.01. What is the ratio of the Production index(2004-2006) of Gabon in 1981 to that in 1984?
Your answer should be compact. 0.94. What is the ratio of the Production index(2004-2006) of Lao PDR in 1981 to that in 1984?
Your answer should be very brief. 0.88. What is the ratio of the Production index(2004-2006) of Euro area in 1981 to that in 1985?
Offer a very short reply. 0.94. What is the ratio of the Production index(2004-2006) of Gabon in 1981 to that in 1985?
Make the answer very short. 0.94. What is the ratio of the Production index(2004-2006) in Lao PDR in 1981 to that in 1985?
Provide a short and direct response. 0.85. What is the ratio of the Production index(2004-2006) of Euro area in 1981 to that in 1986?
Keep it short and to the point. 0.93. What is the ratio of the Production index(2004-2006) in Cayman Islands in 1981 to that in 1986?
Make the answer very short. 1.37. What is the ratio of the Production index(2004-2006) in Gabon in 1981 to that in 1986?
Offer a very short reply. 0.9. What is the ratio of the Production index(2004-2006) in Lao PDR in 1981 to that in 1986?
Give a very brief answer. 0.82. What is the ratio of the Production index(2004-2006) in Euro area in 1982 to that in 1983?
Give a very brief answer. 1.02. What is the ratio of the Production index(2004-2006) of Cayman Islands in 1982 to that in 1983?
Your answer should be compact. 0.86. What is the ratio of the Production index(2004-2006) of Gabon in 1982 to that in 1983?
Your answer should be compact. 0.97. What is the ratio of the Production index(2004-2006) of Lao PDR in 1982 to that in 1983?
Give a very brief answer. 0.98. What is the ratio of the Production index(2004-2006) in Euro area in 1982 to that in 1984?
Offer a terse response. 0.98. What is the ratio of the Production index(2004-2006) in Cayman Islands in 1982 to that in 1984?
Provide a short and direct response. 1.05. What is the ratio of the Production index(2004-2006) in Gabon in 1982 to that in 1984?
Offer a very short reply. 0.95. What is the ratio of the Production index(2004-2006) of Lao PDR in 1982 to that in 1984?
Provide a succinct answer. 0.86. What is the ratio of the Production index(2004-2006) of Cayman Islands in 1982 to that in 1985?
Offer a terse response. 1.05. What is the ratio of the Production index(2004-2006) in Gabon in 1982 to that in 1985?
Your answer should be very brief. 0.95. What is the ratio of the Production index(2004-2006) in Lao PDR in 1982 to that in 1985?
Give a very brief answer. 0.83. What is the ratio of the Production index(2004-2006) in Euro area in 1982 to that in 1986?
Your answer should be compact. 0.98. What is the ratio of the Production index(2004-2006) in Cayman Islands in 1982 to that in 1986?
Offer a terse response. 1.42. What is the ratio of the Production index(2004-2006) in Gabon in 1982 to that in 1986?
Ensure brevity in your answer.  0.91. What is the ratio of the Production index(2004-2006) of Lao PDR in 1982 to that in 1986?
Provide a succinct answer. 0.8. What is the ratio of the Production index(2004-2006) in Euro area in 1983 to that in 1984?
Offer a terse response. 0.96. What is the ratio of the Production index(2004-2006) in Cayman Islands in 1983 to that in 1984?
Offer a terse response. 1.22. What is the ratio of the Production index(2004-2006) of Gabon in 1983 to that in 1984?
Offer a very short reply. 0.98. What is the ratio of the Production index(2004-2006) of Lao PDR in 1983 to that in 1984?
Make the answer very short. 0.87. What is the ratio of the Production index(2004-2006) in Euro area in 1983 to that in 1985?
Provide a short and direct response. 0.97. What is the ratio of the Production index(2004-2006) of Cayman Islands in 1983 to that in 1985?
Your answer should be compact. 1.21. What is the ratio of the Production index(2004-2006) of Gabon in 1983 to that in 1985?
Make the answer very short. 0.98. What is the ratio of the Production index(2004-2006) in Lao PDR in 1983 to that in 1985?
Your answer should be compact. 0.84. What is the ratio of the Production index(2004-2006) in Euro area in 1983 to that in 1986?
Offer a very short reply. 0.97. What is the ratio of the Production index(2004-2006) of Cayman Islands in 1983 to that in 1986?
Keep it short and to the point. 1.65. What is the ratio of the Production index(2004-2006) in Gabon in 1983 to that in 1986?
Provide a short and direct response. 0.93. What is the ratio of the Production index(2004-2006) of Lao PDR in 1983 to that in 1986?
Ensure brevity in your answer.  0.81. What is the ratio of the Production index(2004-2006) in Euro area in 1984 to that in 1985?
Keep it short and to the point. 1.01. What is the ratio of the Production index(2004-2006) of Cayman Islands in 1984 to that in 1985?
Keep it short and to the point. 0.99. What is the ratio of the Production index(2004-2006) of Lao PDR in 1984 to that in 1985?
Offer a very short reply. 0.97. What is the ratio of the Production index(2004-2006) of Cayman Islands in 1984 to that in 1986?
Your response must be concise. 1.35. What is the ratio of the Production index(2004-2006) in Gabon in 1984 to that in 1986?
Your answer should be very brief. 0.95. What is the ratio of the Production index(2004-2006) in Lao PDR in 1984 to that in 1986?
Provide a short and direct response. 0.93. What is the ratio of the Production index(2004-2006) of Cayman Islands in 1985 to that in 1986?
Make the answer very short. 1.36. What is the ratio of the Production index(2004-2006) in Gabon in 1985 to that in 1986?
Provide a short and direct response. 0.96. What is the difference between the highest and the second highest Production index(2004-2006) in Euro area?
Keep it short and to the point. 0.39. What is the difference between the highest and the second highest Production index(2004-2006) of Cayman Islands?
Your response must be concise. 33.64. What is the difference between the highest and the second highest Production index(2004-2006) of Gabon?
Your answer should be compact. 3.63. What is the difference between the highest and the second highest Production index(2004-2006) of Lao PDR?
Keep it short and to the point. 1.68. What is the difference between the highest and the lowest Production index(2004-2006) of Euro area?
Your answer should be compact. 6.65. What is the difference between the highest and the lowest Production index(2004-2006) in Cayman Islands?
Provide a short and direct response. 113.5. What is the difference between the highest and the lowest Production index(2004-2006) in Gabon?
Provide a short and direct response. 9.44. What is the difference between the highest and the lowest Production index(2004-2006) in Lao PDR?
Your response must be concise. 16.14. 